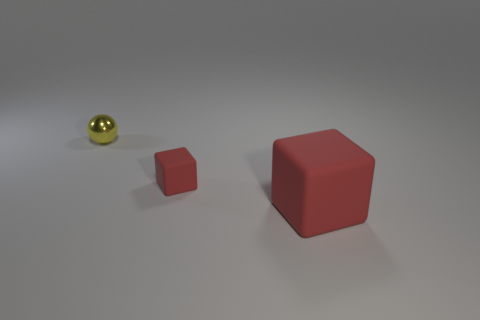What are the apparent materials of the objects in this image? The sphere has a shiny, metallic luster, suggesting it might be metal or coated with a reflective material. The larger cube has a matte surface, likely indicating a plastic or painted surface. The small cube shares the same matte finish, suggesting a similar composition. Could the size of the objects imply anything about their use or function? If we are to speculate based on size alone, the larger cube could serve as a container or a decorative piece, whereas the smaller cube might be a child's toy or a scale model. The sphere, given its finish and isolated position, could be a decorative object or part of a larger mechanism. 